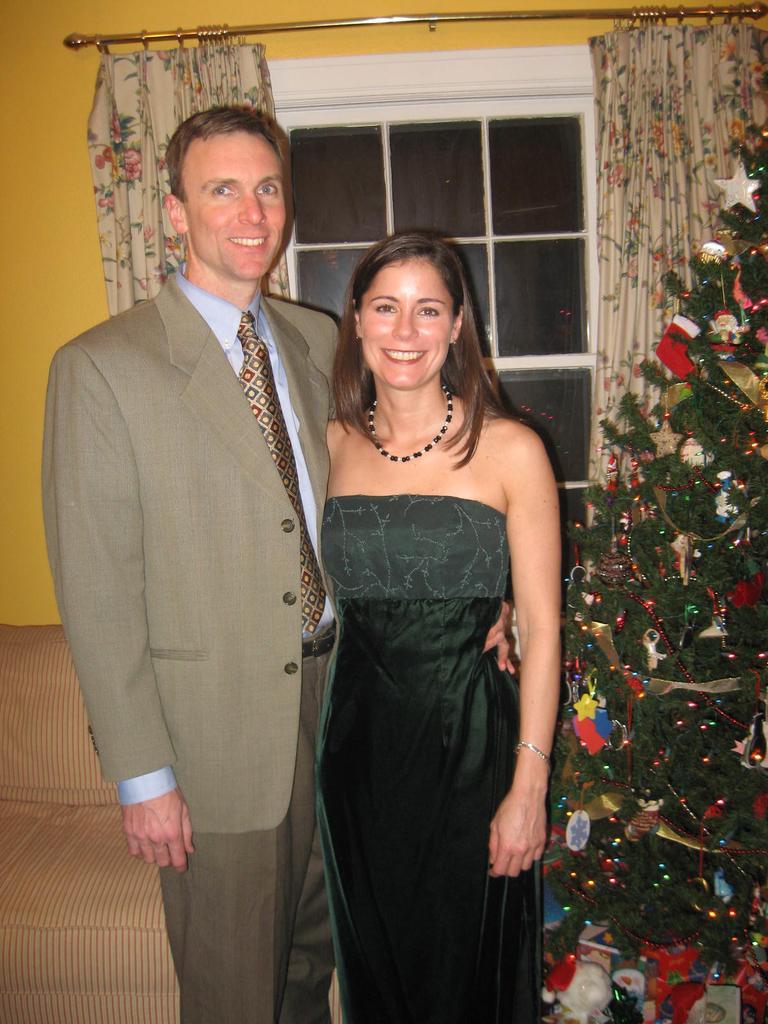Can you describe this image briefly? In the foreground of this image, there is a couple standing and posing to a camera. On the right, there is a Xmas tree. In the background, there is a couch, wall, curtain and a window. 